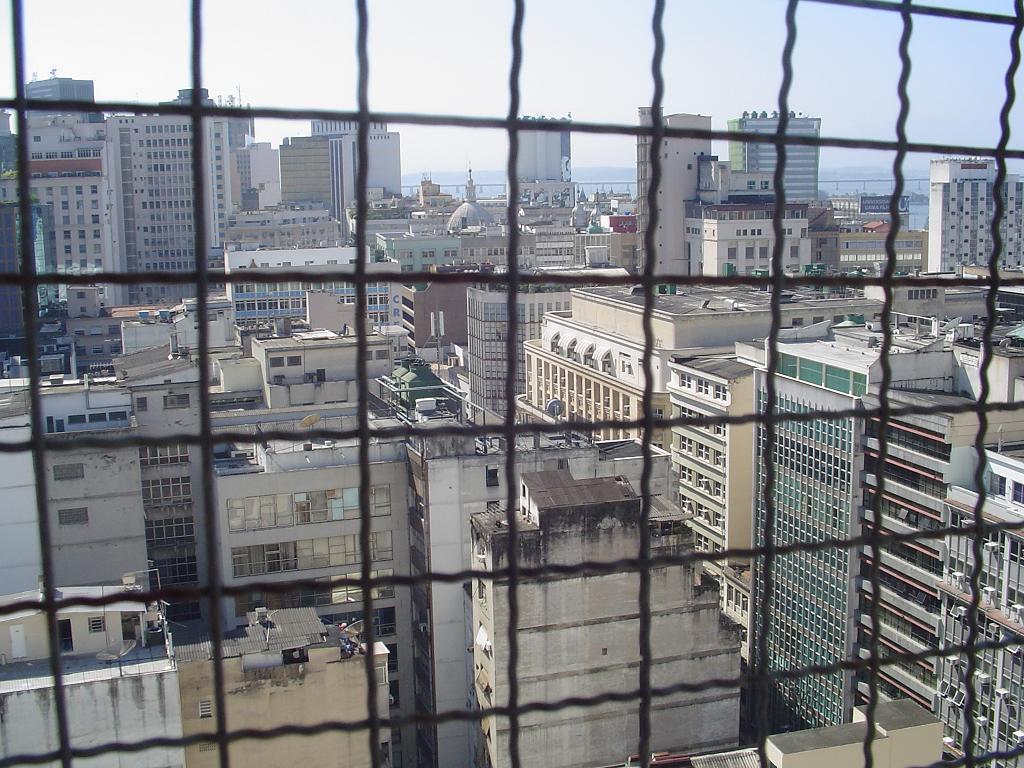Could you give a brief overview of what you see in this image? In this image we can see steel railing through which we can see the tower buildings and the sky in the background. 